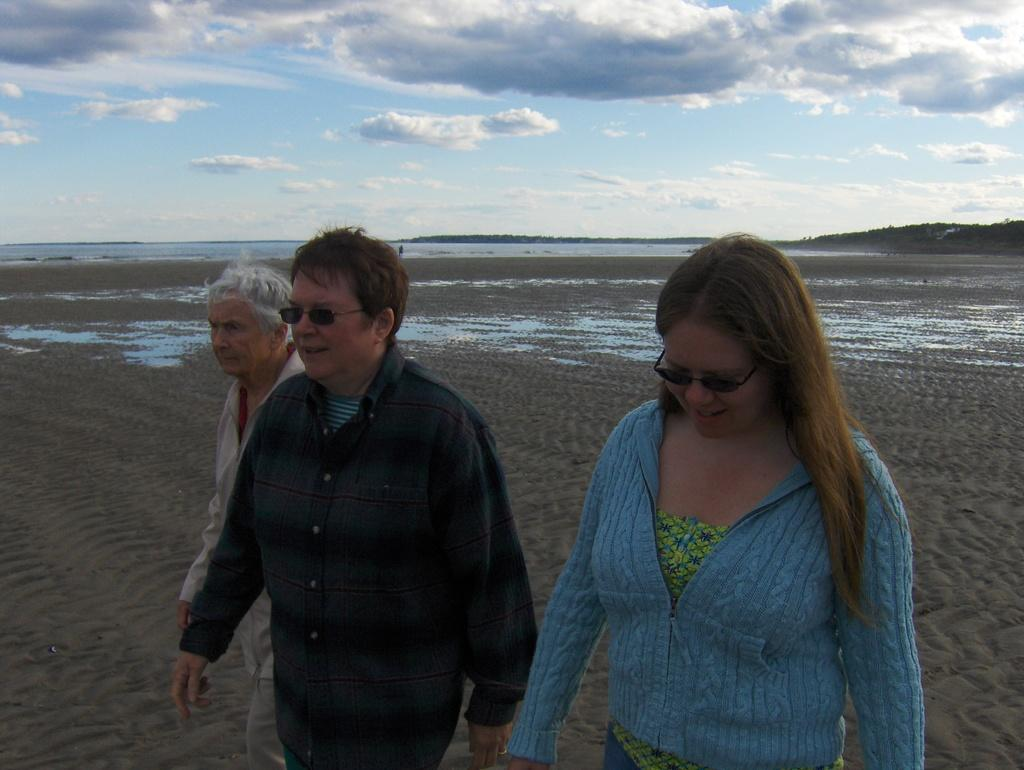How many people are in the image? There are three people in the image. What are the people doing in the image? The people are walking on the sand. What can be seen in the background of the image? There is a river and the sky visible in the background. How many clocks are present on the sand in the image? There are no clocks visible on the sand in the image. 